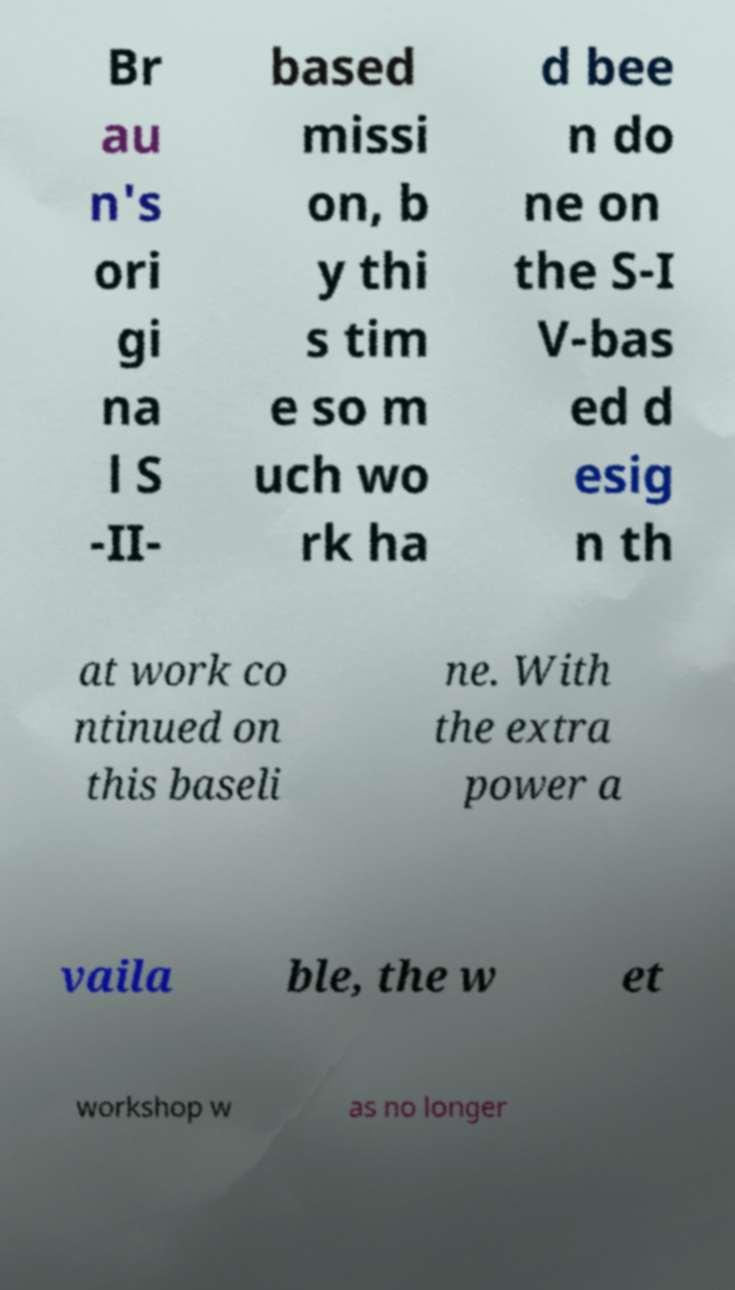Please identify and transcribe the text found in this image. Br au n's ori gi na l S -II- based missi on, b y thi s tim e so m uch wo rk ha d bee n do ne on the S-I V-bas ed d esig n th at work co ntinued on this baseli ne. With the extra power a vaila ble, the w et workshop w as no longer 